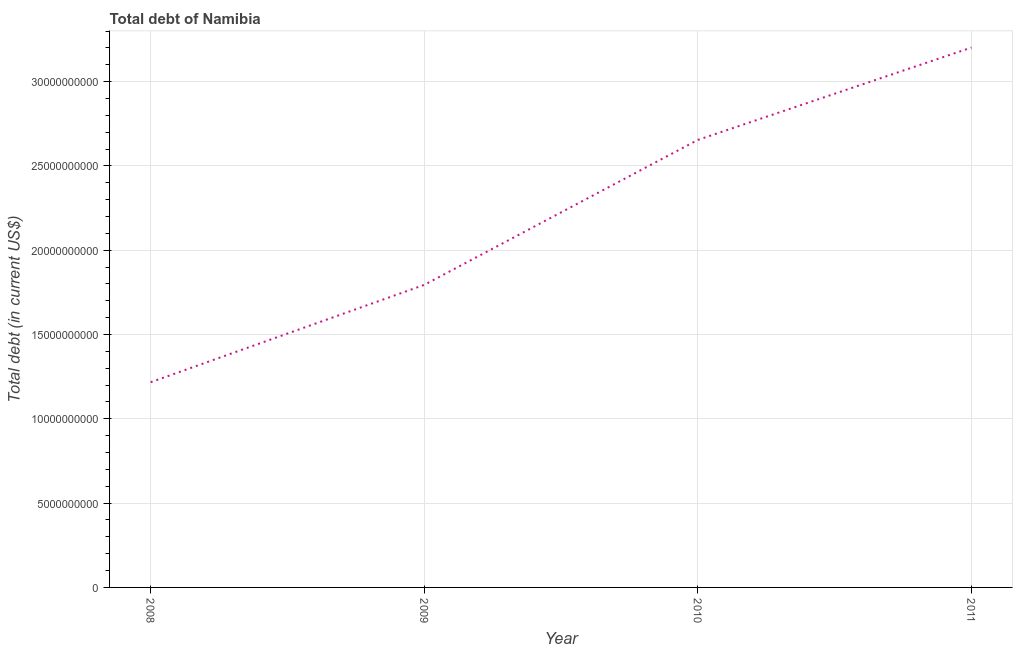What is the total debt in 2010?
Ensure brevity in your answer.  2.65e+1. Across all years, what is the maximum total debt?
Your answer should be compact. 3.20e+1. Across all years, what is the minimum total debt?
Ensure brevity in your answer.  1.22e+1. In which year was the total debt maximum?
Provide a short and direct response. 2011. What is the sum of the total debt?
Give a very brief answer. 8.87e+1. What is the difference between the total debt in 2009 and 2010?
Your response must be concise. -8.60e+09. What is the average total debt per year?
Your answer should be very brief. 2.22e+1. What is the median total debt?
Your response must be concise. 2.22e+1. In how many years, is the total debt greater than 6000000000 US$?
Offer a terse response. 4. Do a majority of the years between 2010 and 2008 (inclusive) have total debt greater than 23000000000 US$?
Give a very brief answer. No. What is the ratio of the total debt in 2008 to that in 2011?
Your answer should be compact. 0.38. Is the total debt in 2008 less than that in 2011?
Your answer should be very brief. Yes. Is the difference between the total debt in 2010 and 2011 greater than the difference between any two years?
Your answer should be very brief. No. What is the difference between the highest and the second highest total debt?
Provide a succinct answer. 5.48e+09. Is the sum of the total debt in 2008 and 2009 greater than the maximum total debt across all years?
Offer a terse response. No. What is the difference between the highest and the lowest total debt?
Provide a succinct answer. 1.98e+1. Does the graph contain any zero values?
Your answer should be very brief. No. Does the graph contain grids?
Provide a short and direct response. Yes. What is the title of the graph?
Keep it short and to the point. Total debt of Namibia. What is the label or title of the Y-axis?
Your answer should be very brief. Total debt (in current US$). What is the Total debt (in current US$) in 2008?
Provide a succinct answer. 1.22e+1. What is the Total debt (in current US$) in 2009?
Offer a very short reply. 1.79e+1. What is the Total debt (in current US$) in 2010?
Offer a terse response. 2.65e+1. What is the Total debt (in current US$) of 2011?
Your answer should be very brief. 3.20e+1. What is the difference between the Total debt (in current US$) in 2008 and 2009?
Keep it short and to the point. -5.77e+09. What is the difference between the Total debt (in current US$) in 2008 and 2010?
Give a very brief answer. -1.44e+1. What is the difference between the Total debt (in current US$) in 2008 and 2011?
Give a very brief answer. -1.98e+1. What is the difference between the Total debt (in current US$) in 2009 and 2010?
Your answer should be compact. -8.60e+09. What is the difference between the Total debt (in current US$) in 2009 and 2011?
Your response must be concise. -1.41e+1. What is the difference between the Total debt (in current US$) in 2010 and 2011?
Your answer should be compact. -5.48e+09. What is the ratio of the Total debt (in current US$) in 2008 to that in 2009?
Make the answer very short. 0.68. What is the ratio of the Total debt (in current US$) in 2008 to that in 2010?
Keep it short and to the point. 0.46. What is the ratio of the Total debt (in current US$) in 2008 to that in 2011?
Your response must be concise. 0.38. What is the ratio of the Total debt (in current US$) in 2009 to that in 2010?
Offer a very short reply. 0.68. What is the ratio of the Total debt (in current US$) in 2009 to that in 2011?
Your response must be concise. 0.56. What is the ratio of the Total debt (in current US$) in 2010 to that in 2011?
Make the answer very short. 0.83. 